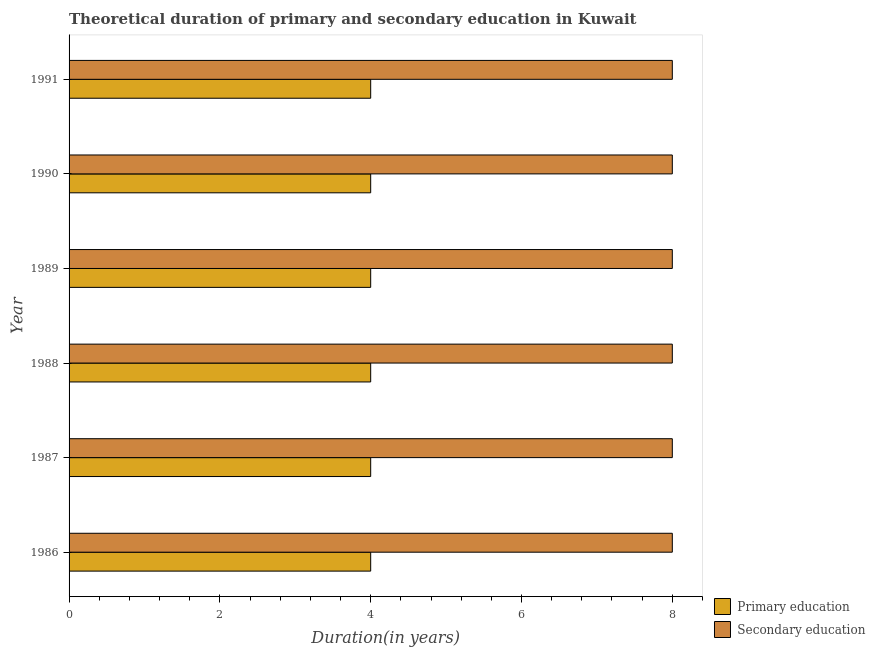How many groups of bars are there?
Give a very brief answer. 6. Are the number of bars per tick equal to the number of legend labels?
Offer a very short reply. Yes. Are the number of bars on each tick of the Y-axis equal?
Your answer should be very brief. Yes. How many bars are there on the 6th tick from the top?
Give a very brief answer. 2. In how many cases, is the number of bars for a given year not equal to the number of legend labels?
Keep it short and to the point. 0. What is the duration of secondary education in 1987?
Make the answer very short. 8. Across all years, what is the maximum duration of primary education?
Your answer should be very brief. 4. Across all years, what is the minimum duration of primary education?
Your answer should be compact. 4. In which year was the duration of secondary education maximum?
Offer a very short reply. 1986. What is the total duration of primary education in the graph?
Provide a succinct answer. 24. What is the difference between the duration of secondary education in 1986 and the duration of primary education in 1991?
Give a very brief answer. 4. In the year 1989, what is the difference between the duration of secondary education and duration of primary education?
Offer a very short reply. 4. What is the ratio of the duration of primary education in 1986 to that in 1988?
Provide a short and direct response. 1. What is the difference between the highest and the lowest duration of secondary education?
Offer a terse response. 0. In how many years, is the duration of primary education greater than the average duration of primary education taken over all years?
Your response must be concise. 0. Is the sum of the duration of primary education in 1988 and 1991 greater than the maximum duration of secondary education across all years?
Offer a very short reply. No. How many bars are there?
Your response must be concise. 12. What is the difference between two consecutive major ticks on the X-axis?
Your answer should be compact. 2. Are the values on the major ticks of X-axis written in scientific E-notation?
Ensure brevity in your answer.  No. Does the graph contain grids?
Your answer should be compact. No. How many legend labels are there?
Keep it short and to the point. 2. What is the title of the graph?
Provide a short and direct response. Theoretical duration of primary and secondary education in Kuwait. What is the label or title of the X-axis?
Provide a short and direct response. Duration(in years). What is the label or title of the Y-axis?
Offer a terse response. Year. What is the Duration(in years) of Secondary education in 1986?
Your response must be concise. 8. What is the Duration(in years) in Secondary education in 1987?
Offer a very short reply. 8. What is the Duration(in years) in Secondary education in 1988?
Offer a terse response. 8. What is the Duration(in years) in Primary education in 1989?
Offer a very short reply. 4. What is the Duration(in years) in Primary education in 1990?
Your response must be concise. 4. What is the Duration(in years) in Secondary education in 1990?
Offer a terse response. 8. What is the Duration(in years) of Primary education in 1991?
Offer a terse response. 4. Across all years, what is the maximum Duration(in years) in Primary education?
Offer a very short reply. 4. Across all years, what is the maximum Duration(in years) of Secondary education?
Your answer should be very brief. 8. Across all years, what is the minimum Duration(in years) in Primary education?
Make the answer very short. 4. What is the difference between the Duration(in years) of Primary education in 1986 and that in 1988?
Offer a very short reply. 0. What is the difference between the Duration(in years) in Primary education in 1986 and that in 1989?
Give a very brief answer. 0. What is the difference between the Duration(in years) in Secondary education in 1986 and that in 1989?
Your answer should be compact. 0. What is the difference between the Duration(in years) in Primary education in 1987 and that in 1988?
Offer a very short reply. 0. What is the difference between the Duration(in years) in Secondary education in 1987 and that in 1988?
Your answer should be very brief. 0. What is the difference between the Duration(in years) in Secondary education in 1987 and that in 1989?
Offer a terse response. 0. What is the difference between the Duration(in years) of Secondary education in 1988 and that in 1989?
Your answer should be very brief. 0. What is the difference between the Duration(in years) in Primary education in 1989 and that in 1990?
Give a very brief answer. 0. What is the difference between the Duration(in years) of Secondary education in 1989 and that in 1990?
Ensure brevity in your answer.  0. What is the difference between the Duration(in years) in Primary education in 1989 and that in 1991?
Your answer should be very brief. 0. What is the difference between the Duration(in years) of Secondary education in 1989 and that in 1991?
Your answer should be compact. 0. What is the difference between the Duration(in years) of Primary education in 1986 and the Duration(in years) of Secondary education in 1989?
Your answer should be compact. -4. What is the difference between the Duration(in years) of Primary education in 1986 and the Duration(in years) of Secondary education in 1991?
Provide a succinct answer. -4. What is the difference between the Duration(in years) of Primary education in 1987 and the Duration(in years) of Secondary education in 1989?
Your response must be concise. -4. What is the difference between the Duration(in years) in Primary education in 1987 and the Duration(in years) in Secondary education in 1990?
Your response must be concise. -4. What is the difference between the Duration(in years) in Primary education in 1987 and the Duration(in years) in Secondary education in 1991?
Provide a short and direct response. -4. What is the difference between the Duration(in years) of Primary education in 1988 and the Duration(in years) of Secondary education in 1989?
Provide a short and direct response. -4. What is the difference between the Duration(in years) of Primary education in 1989 and the Duration(in years) of Secondary education in 1990?
Offer a very short reply. -4. What is the difference between the Duration(in years) in Primary education in 1990 and the Duration(in years) in Secondary education in 1991?
Make the answer very short. -4. What is the average Duration(in years) in Primary education per year?
Make the answer very short. 4. In the year 1986, what is the difference between the Duration(in years) in Primary education and Duration(in years) in Secondary education?
Your response must be concise. -4. In the year 1990, what is the difference between the Duration(in years) of Primary education and Duration(in years) of Secondary education?
Provide a short and direct response. -4. In the year 1991, what is the difference between the Duration(in years) of Primary education and Duration(in years) of Secondary education?
Provide a succinct answer. -4. What is the ratio of the Duration(in years) in Primary education in 1986 to that in 1987?
Offer a terse response. 1. What is the ratio of the Duration(in years) in Secondary education in 1986 to that in 1988?
Your answer should be very brief. 1. What is the ratio of the Duration(in years) in Primary education in 1986 to that in 1990?
Keep it short and to the point. 1. What is the ratio of the Duration(in years) in Primary education in 1986 to that in 1991?
Your answer should be very brief. 1. What is the ratio of the Duration(in years) of Secondary education in 1986 to that in 1991?
Your answer should be compact. 1. What is the ratio of the Duration(in years) in Primary education in 1987 to that in 1988?
Your answer should be very brief. 1. What is the ratio of the Duration(in years) of Secondary education in 1987 to that in 1988?
Your answer should be very brief. 1. What is the ratio of the Duration(in years) of Secondary education in 1987 to that in 1989?
Make the answer very short. 1. What is the ratio of the Duration(in years) of Primary education in 1987 to that in 1990?
Your response must be concise. 1. What is the ratio of the Duration(in years) of Secondary education in 1987 to that in 1990?
Give a very brief answer. 1. What is the ratio of the Duration(in years) of Secondary education in 1987 to that in 1991?
Provide a succinct answer. 1. What is the ratio of the Duration(in years) in Primary education in 1988 to that in 1989?
Your answer should be very brief. 1. What is the ratio of the Duration(in years) of Secondary education in 1988 to that in 1989?
Provide a succinct answer. 1. What is the ratio of the Duration(in years) of Primary education in 1988 to that in 1990?
Ensure brevity in your answer.  1. What is the ratio of the Duration(in years) of Secondary education in 1988 to that in 1990?
Your response must be concise. 1. What is the ratio of the Duration(in years) of Secondary education in 1988 to that in 1991?
Ensure brevity in your answer.  1. What is the ratio of the Duration(in years) in Primary education in 1989 to that in 1991?
Offer a very short reply. 1. What is the ratio of the Duration(in years) in Secondary education in 1990 to that in 1991?
Provide a succinct answer. 1. What is the difference between the highest and the lowest Duration(in years) in Secondary education?
Provide a succinct answer. 0. 